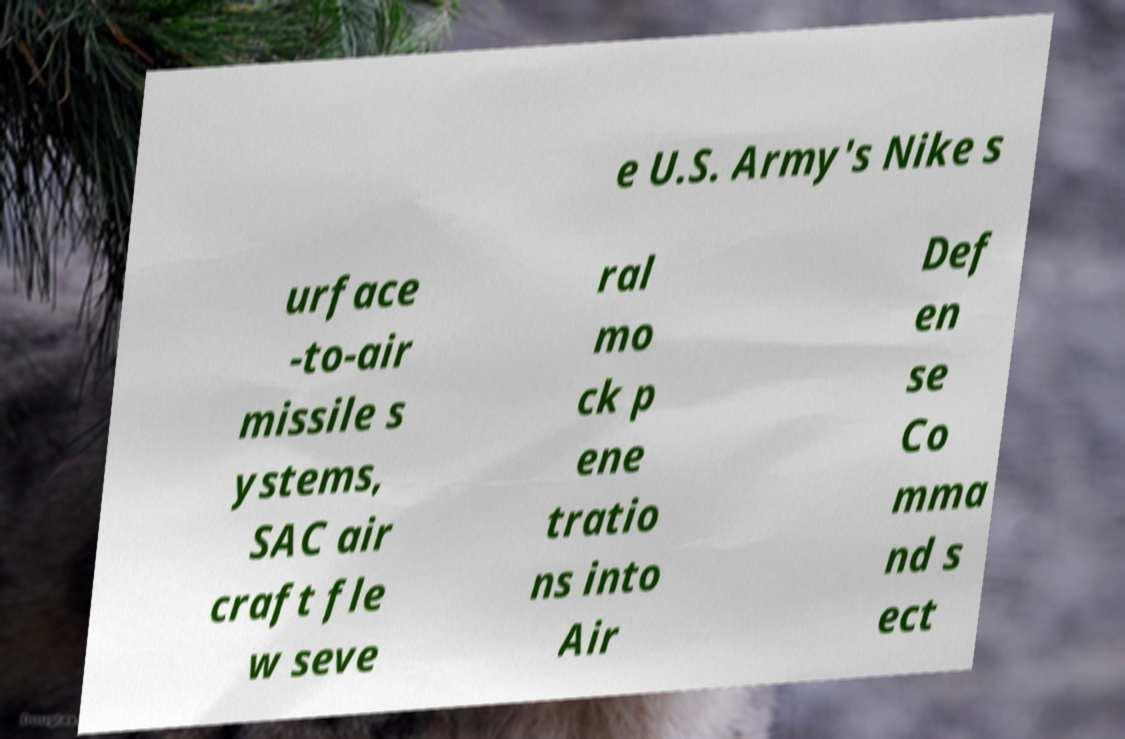Please read and relay the text visible in this image. What does it say? e U.S. Army's Nike s urface -to-air missile s ystems, SAC air craft fle w seve ral mo ck p ene tratio ns into Air Def en se Co mma nd s ect 